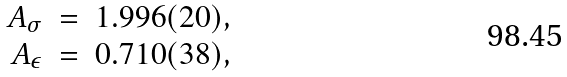Convert formula to latex. <formula><loc_0><loc_0><loc_500><loc_500>\begin{array} { r c l } A _ { \sigma } & = & 1 . 9 9 6 ( 2 0 ) , \\ A _ { \epsilon } & = & 0 . 7 1 0 ( 3 8 ) , \end{array}</formula> 